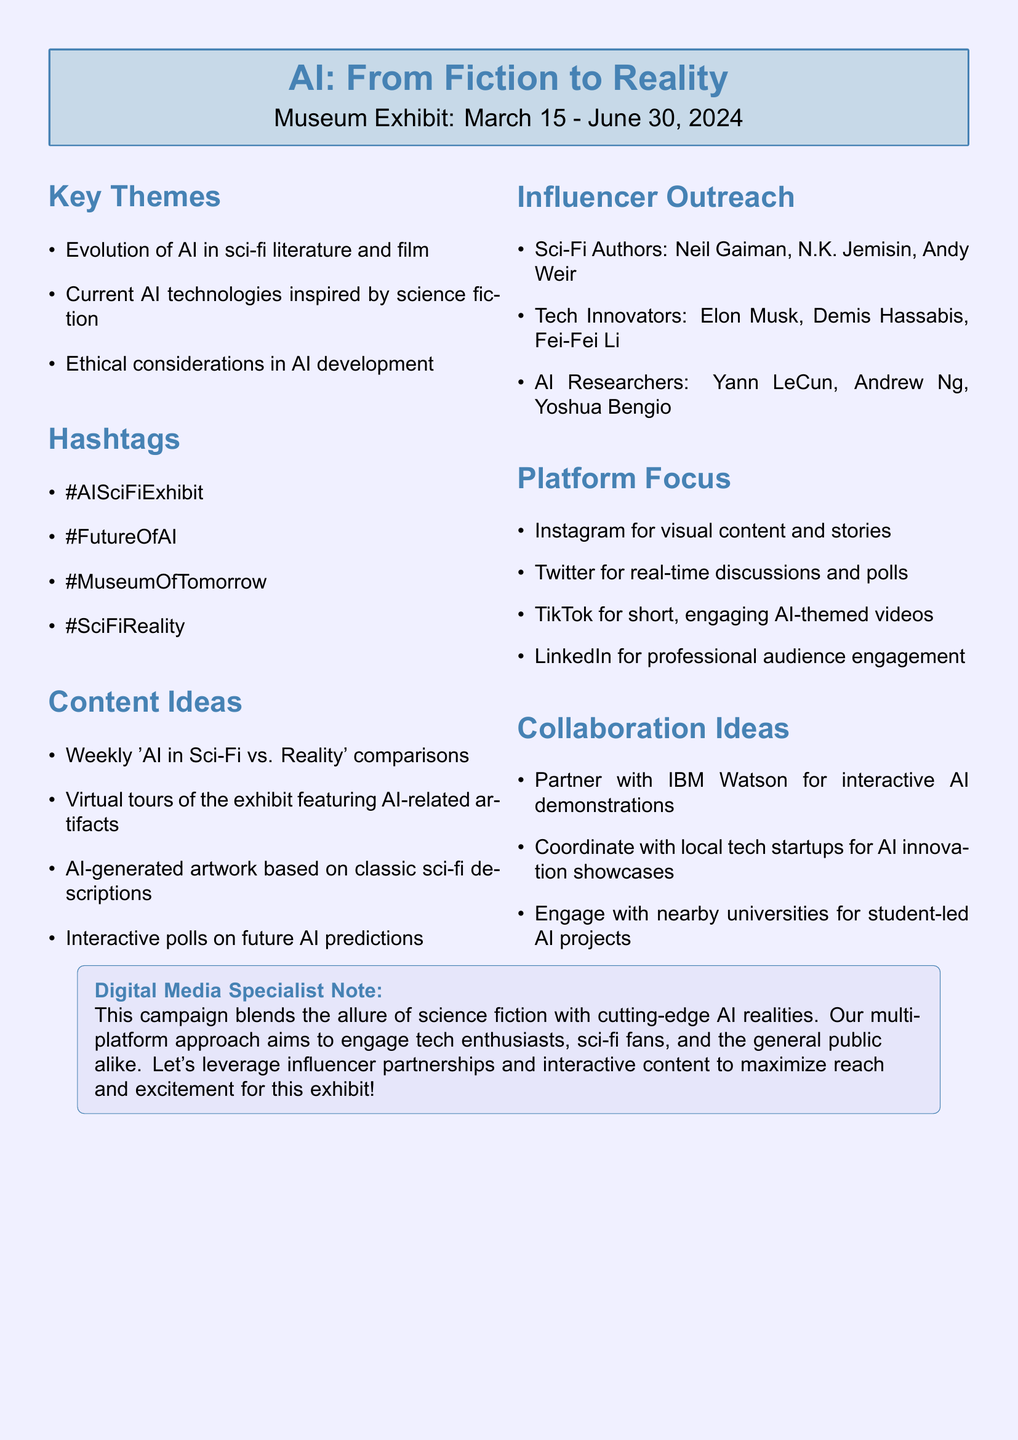What is the campaign title? The campaign title is clearly stated at the beginning of the document.
Answer: AI: From Fiction to Reality When does the exhibit start? The exhibit duration is specified, indicating the start date.
Answer: March 15 What are the key themes of the exhibit? The document lists key themes that highlight the focus areas of the exhibit.
Answer: Evolution of AI in sci-fi literature and film How many hashtags are suggested? The document contains a list of suggested hashtags for the campaign.
Answer: Four Which platform is focused on real-time discussions? The document specifies which social media platform will be used for discussions.
Answer: Twitter What is one of the collaboration ideas? Various collaboration ideas are mentioned in the document for the campaign.
Answer: Partner with IBM Watson Who is listed as a tech innovator in the influencer outreach section? The document names specific individuals in the tech innovator category.
Answer: Elon Musk What type of content idea involves AI-generated artwork? The content ideas provide specific ways to engage audiences, including one idea related to AI art.
Answer: AI-generated artwork based on classic sci-fi descriptions What is one of the key themes about AI development? The document highlights several themes, including one that pertains to ethical aspects.
Answer: Ethical considerations in AI development 